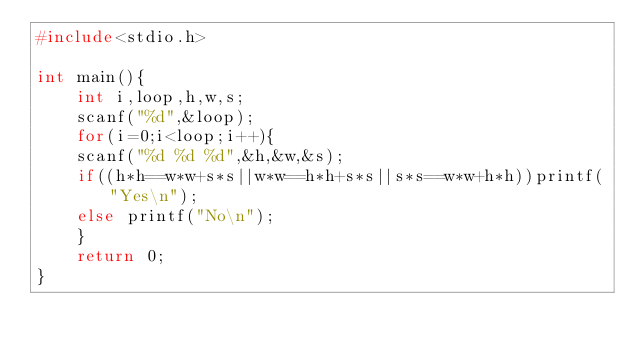Convert code to text. <code><loc_0><loc_0><loc_500><loc_500><_C_>#include<stdio.h>

int main(){
    int i,loop,h,w,s;
    scanf("%d",&loop);
    for(i=0;i<loop;i++){
    scanf("%d %d %d",&h,&w,&s);
    if((h*h==w*w+s*s||w*w==h*h+s*s||s*s==w*w+h*h))printf("Yes\n");
    else printf("No\n");
    }
    return 0;
}</code> 